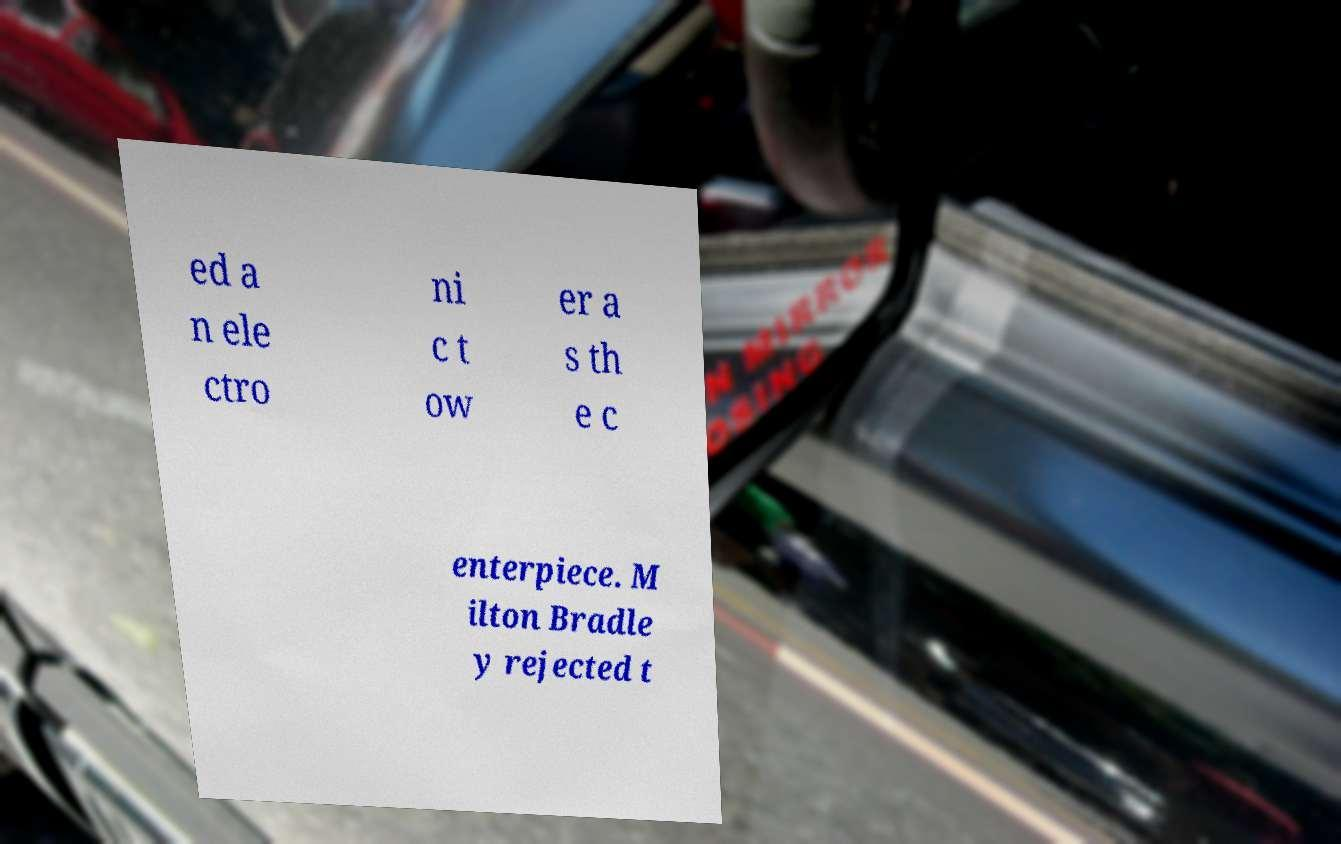Please read and relay the text visible in this image. What does it say? ed a n ele ctro ni c t ow er a s th e c enterpiece. M ilton Bradle y rejected t 